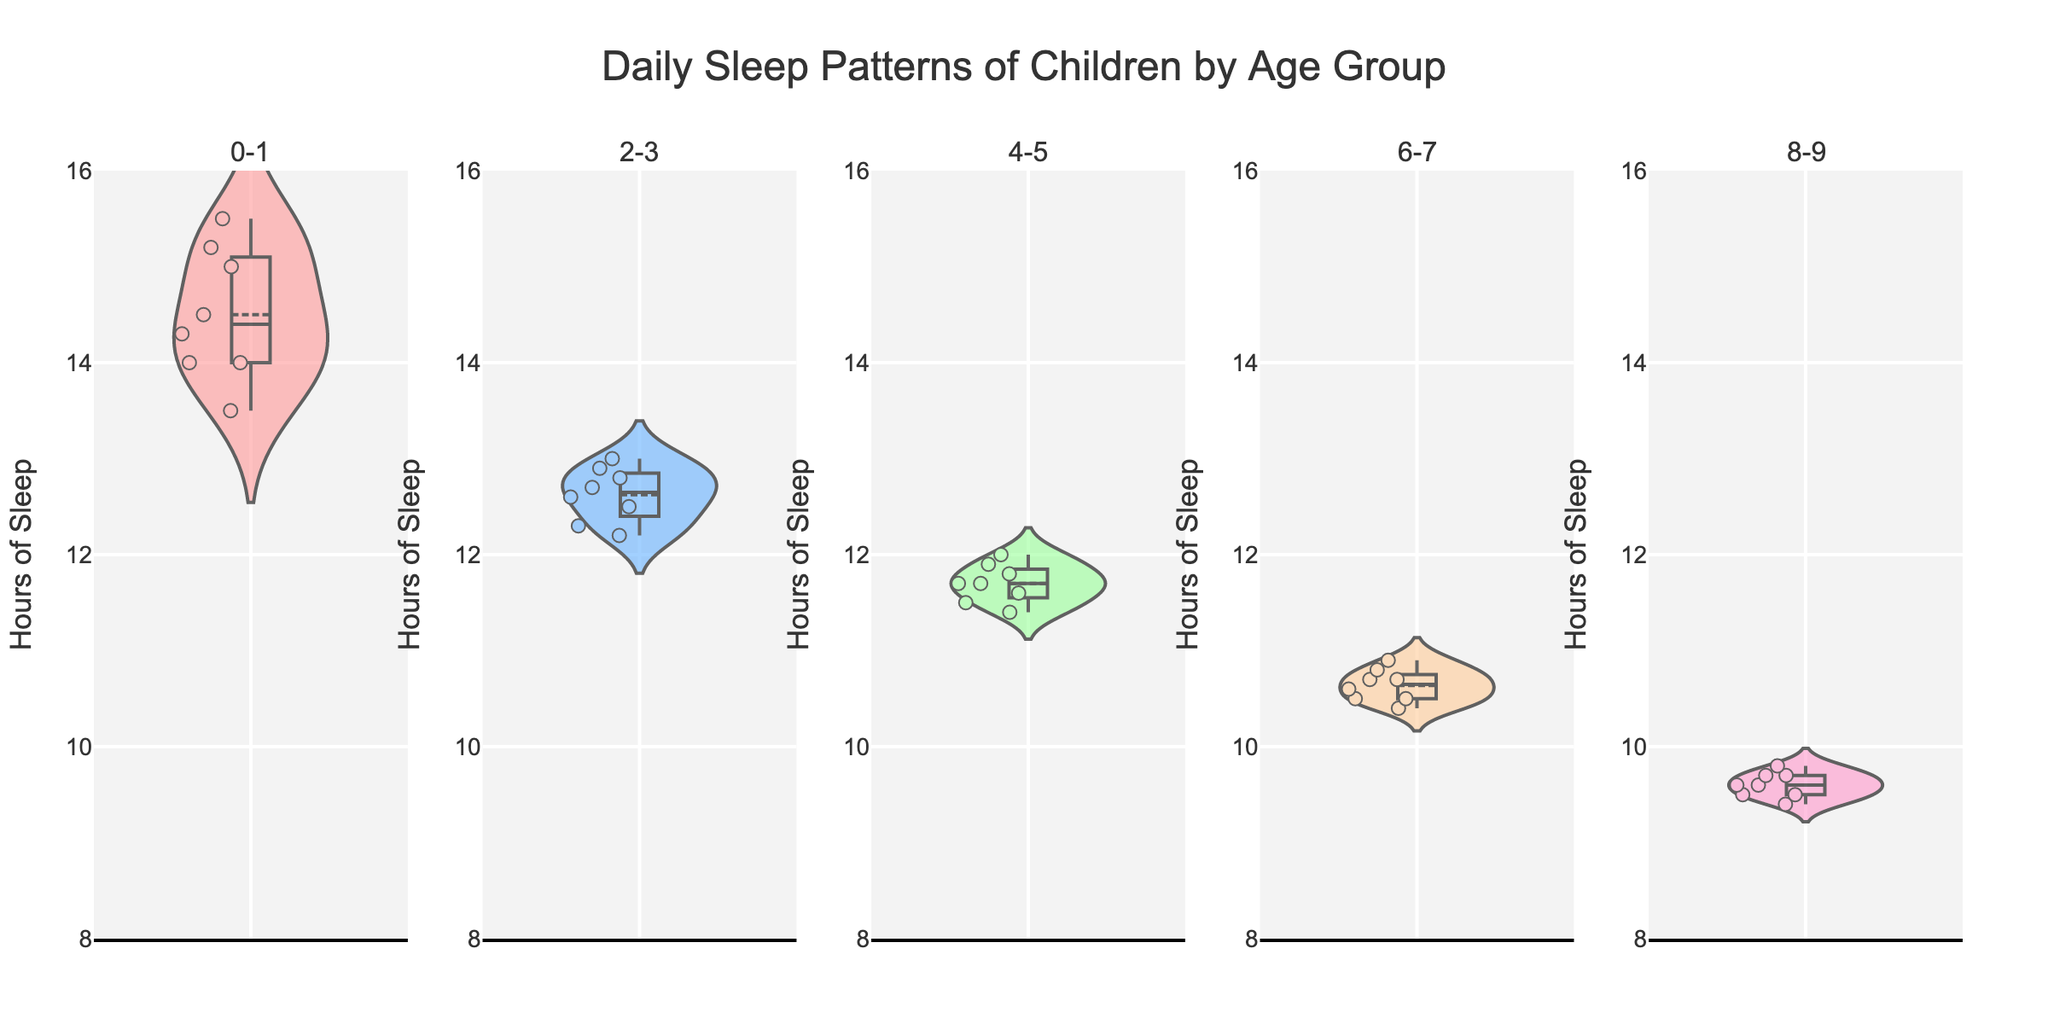Which age group has the widest range of sleep hours? Look at each violin plot and compare the spread of the data points. The 0-1 age group's plot shows the widest spread, ranging from around 13.5 to 15.5 hours.
Answer: 0-1 What is the median sleep duration for the 2-3 age group? Check the median line of the violin plot for the 2-3 age group. It appears to be around 12.7 hours.
Answer: 12.7 hours How does the average sleep duration change from the 4-5 age group to the 6-7 age group? Observe the mean lines in the violin plots for both age groups. The 4-5 age group averages around 11.7 hours, while the 6-7 age group averages around 10.7 hours. There is a decrease of approximately 1 hour.
Answer: Decreases by 1 hour Which group has the least variability in sleep hours? Look for the violin plot with the smallest spread of data points. The 6-7 age group has the least variability, with sleep hours tightly clustered around 10.5 to 10.9 hours.
Answer: 6-7 What is the approximate range of sleep hours for the 8-9 age group? Check the spread of data points in the violin plot for the 8-9 age group. The sleep hours range from around 9.4 to 9.8 hours.
Answer: 9.4 to 9.8 hours How do the sleep patterns change as age increases from 0-1 to 2-3 years old? Compare the violin plots for the 0-1 and 2-3 age groups. The 0-1 age group has a wider spread of sleep hours (13.5 to 15.5), while the 2-3 age group shows a narrower range (12.2 to 13). The overall sleep hours decrease.
Answer: Decrease and narrow in range Which age group has the highest median sleep duration? Look at the median lines in each violin plot and compare them. The 0-1 age group has the highest median sleep duration of around 14.5 hours.
Answer: 0-1 How many age groups are compared in the figure? Count the number of subplots in the figure. There are five distinct subplots, each representing an age group.
Answer: Five 